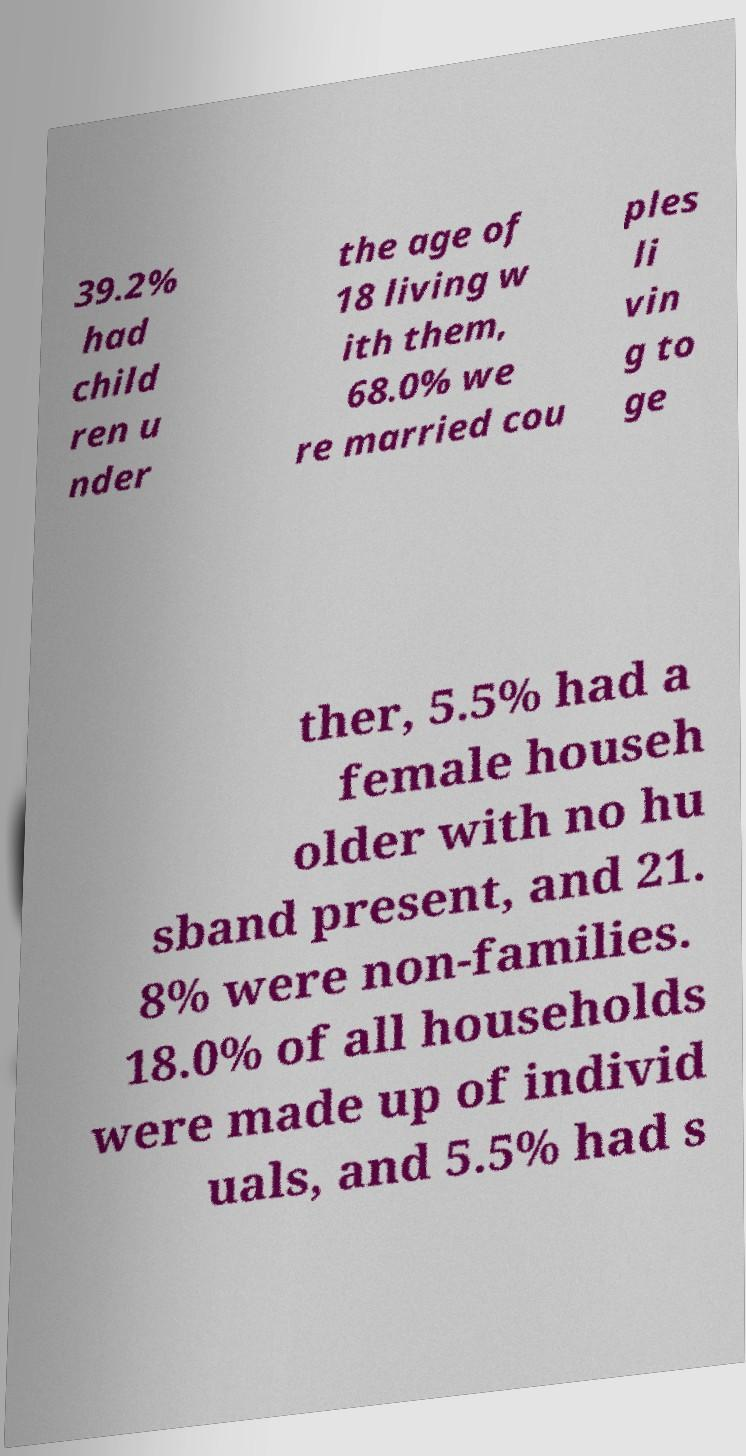I need the written content from this picture converted into text. Can you do that? 39.2% had child ren u nder the age of 18 living w ith them, 68.0% we re married cou ples li vin g to ge ther, 5.5% had a female househ older with no hu sband present, and 21. 8% were non-families. 18.0% of all households were made up of individ uals, and 5.5% had s 